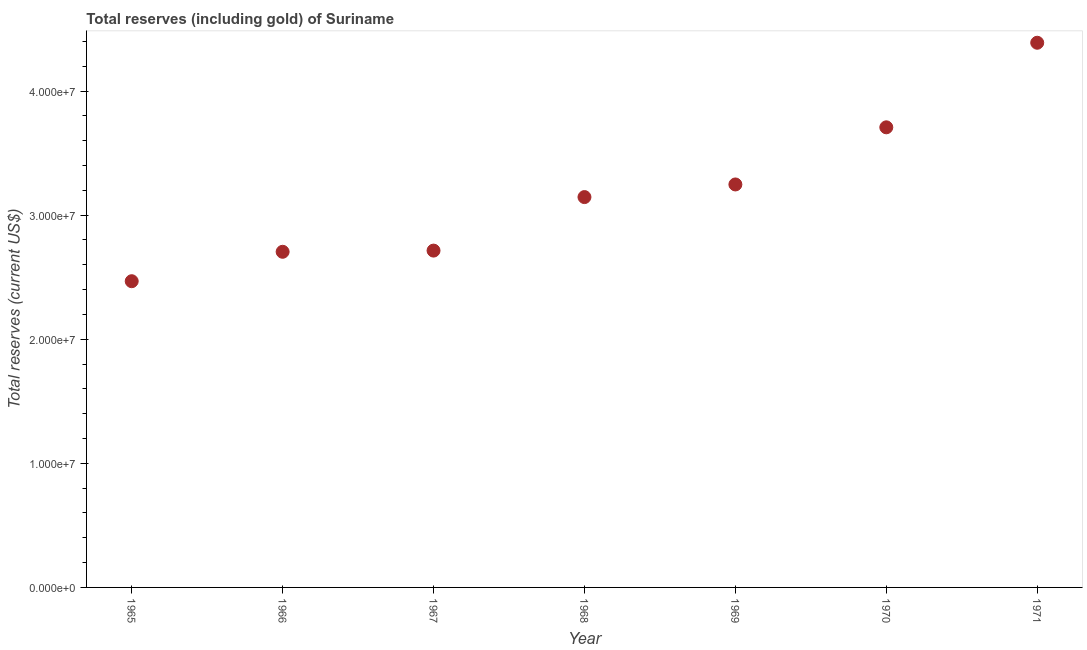What is the total reserves (including gold) in 1968?
Make the answer very short. 3.15e+07. Across all years, what is the maximum total reserves (including gold)?
Ensure brevity in your answer.  4.39e+07. Across all years, what is the minimum total reserves (including gold)?
Your response must be concise. 2.47e+07. In which year was the total reserves (including gold) maximum?
Make the answer very short. 1971. In which year was the total reserves (including gold) minimum?
Make the answer very short. 1965. What is the sum of the total reserves (including gold)?
Your response must be concise. 2.24e+08. What is the difference between the total reserves (including gold) in 1965 and 1968?
Offer a terse response. -6.78e+06. What is the average total reserves (including gold) per year?
Make the answer very short. 3.20e+07. What is the median total reserves (including gold)?
Your response must be concise. 3.15e+07. Do a majority of the years between 1966 and 1965 (inclusive) have total reserves (including gold) greater than 34000000 US$?
Provide a short and direct response. No. What is the ratio of the total reserves (including gold) in 1965 to that in 1967?
Your answer should be compact. 0.91. Is the total reserves (including gold) in 1969 less than that in 1970?
Your answer should be very brief. Yes. What is the difference between the highest and the second highest total reserves (including gold)?
Ensure brevity in your answer.  6.82e+06. What is the difference between the highest and the lowest total reserves (including gold)?
Keep it short and to the point. 1.92e+07. In how many years, is the total reserves (including gold) greater than the average total reserves (including gold) taken over all years?
Your answer should be compact. 3. How many years are there in the graph?
Offer a terse response. 7. What is the difference between two consecutive major ticks on the Y-axis?
Ensure brevity in your answer.  1.00e+07. Are the values on the major ticks of Y-axis written in scientific E-notation?
Provide a short and direct response. Yes. Does the graph contain any zero values?
Your response must be concise. No. Does the graph contain grids?
Give a very brief answer. No. What is the title of the graph?
Your answer should be compact. Total reserves (including gold) of Suriname. What is the label or title of the X-axis?
Keep it short and to the point. Year. What is the label or title of the Y-axis?
Offer a terse response. Total reserves (current US$). What is the Total reserves (current US$) in 1965?
Offer a very short reply. 2.47e+07. What is the Total reserves (current US$) in 1966?
Your answer should be very brief. 2.70e+07. What is the Total reserves (current US$) in 1967?
Your response must be concise. 2.71e+07. What is the Total reserves (current US$) in 1968?
Keep it short and to the point. 3.15e+07. What is the Total reserves (current US$) in 1969?
Provide a short and direct response. 3.25e+07. What is the Total reserves (current US$) in 1970?
Provide a succinct answer. 3.71e+07. What is the Total reserves (current US$) in 1971?
Provide a short and direct response. 4.39e+07. What is the difference between the Total reserves (current US$) in 1965 and 1966?
Make the answer very short. -2.37e+06. What is the difference between the Total reserves (current US$) in 1965 and 1967?
Ensure brevity in your answer.  -2.47e+06. What is the difference between the Total reserves (current US$) in 1965 and 1968?
Offer a terse response. -6.78e+06. What is the difference between the Total reserves (current US$) in 1965 and 1969?
Offer a very short reply. -7.80e+06. What is the difference between the Total reserves (current US$) in 1965 and 1970?
Your response must be concise. -1.24e+07. What is the difference between the Total reserves (current US$) in 1965 and 1971?
Provide a short and direct response. -1.92e+07. What is the difference between the Total reserves (current US$) in 1966 and 1967?
Offer a very short reply. -9.55e+04. What is the difference between the Total reserves (current US$) in 1966 and 1968?
Make the answer very short. -4.41e+06. What is the difference between the Total reserves (current US$) in 1966 and 1969?
Make the answer very short. -5.43e+06. What is the difference between the Total reserves (current US$) in 1966 and 1970?
Your answer should be compact. -1.00e+07. What is the difference between the Total reserves (current US$) in 1966 and 1971?
Ensure brevity in your answer.  -1.68e+07. What is the difference between the Total reserves (current US$) in 1967 and 1968?
Your answer should be very brief. -4.31e+06. What is the difference between the Total reserves (current US$) in 1967 and 1969?
Ensure brevity in your answer.  -5.33e+06. What is the difference between the Total reserves (current US$) in 1967 and 1970?
Your answer should be compact. -9.93e+06. What is the difference between the Total reserves (current US$) in 1967 and 1971?
Keep it short and to the point. -1.68e+07. What is the difference between the Total reserves (current US$) in 1968 and 1969?
Your answer should be compact. -1.02e+06. What is the difference between the Total reserves (current US$) in 1968 and 1970?
Offer a terse response. -5.62e+06. What is the difference between the Total reserves (current US$) in 1968 and 1971?
Offer a very short reply. -1.24e+07. What is the difference between the Total reserves (current US$) in 1969 and 1970?
Your answer should be very brief. -4.60e+06. What is the difference between the Total reserves (current US$) in 1969 and 1971?
Give a very brief answer. -1.14e+07. What is the difference between the Total reserves (current US$) in 1970 and 1971?
Your response must be concise. -6.82e+06. What is the ratio of the Total reserves (current US$) in 1965 to that in 1966?
Make the answer very short. 0.91. What is the ratio of the Total reserves (current US$) in 1965 to that in 1967?
Make the answer very short. 0.91. What is the ratio of the Total reserves (current US$) in 1965 to that in 1968?
Offer a terse response. 0.78. What is the ratio of the Total reserves (current US$) in 1965 to that in 1969?
Your answer should be compact. 0.76. What is the ratio of the Total reserves (current US$) in 1965 to that in 1970?
Your answer should be compact. 0.67. What is the ratio of the Total reserves (current US$) in 1965 to that in 1971?
Provide a succinct answer. 0.56. What is the ratio of the Total reserves (current US$) in 1966 to that in 1967?
Provide a succinct answer. 1. What is the ratio of the Total reserves (current US$) in 1966 to that in 1968?
Offer a terse response. 0.86. What is the ratio of the Total reserves (current US$) in 1966 to that in 1969?
Offer a very short reply. 0.83. What is the ratio of the Total reserves (current US$) in 1966 to that in 1970?
Give a very brief answer. 0.73. What is the ratio of the Total reserves (current US$) in 1966 to that in 1971?
Give a very brief answer. 0.62. What is the ratio of the Total reserves (current US$) in 1967 to that in 1968?
Your response must be concise. 0.86. What is the ratio of the Total reserves (current US$) in 1967 to that in 1969?
Offer a terse response. 0.84. What is the ratio of the Total reserves (current US$) in 1967 to that in 1970?
Ensure brevity in your answer.  0.73. What is the ratio of the Total reserves (current US$) in 1967 to that in 1971?
Your response must be concise. 0.62. What is the ratio of the Total reserves (current US$) in 1968 to that in 1969?
Provide a short and direct response. 0.97. What is the ratio of the Total reserves (current US$) in 1968 to that in 1970?
Your answer should be compact. 0.85. What is the ratio of the Total reserves (current US$) in 1968 to that in 1971?
Offer a terse response. 0.72. What is the ratio of the Total reserves (current US$) in 1969 to that in 1970?
Your response must be concise. 0.88. What is the ratio of the Total reserves (current US$) in 1969 to that in 1971?
Provide a short and direct response. 0.74. What is the ratio of the Total reserves (current US$) in 1970 to that in 1971?
Keep it short and to the point. 0.84. 